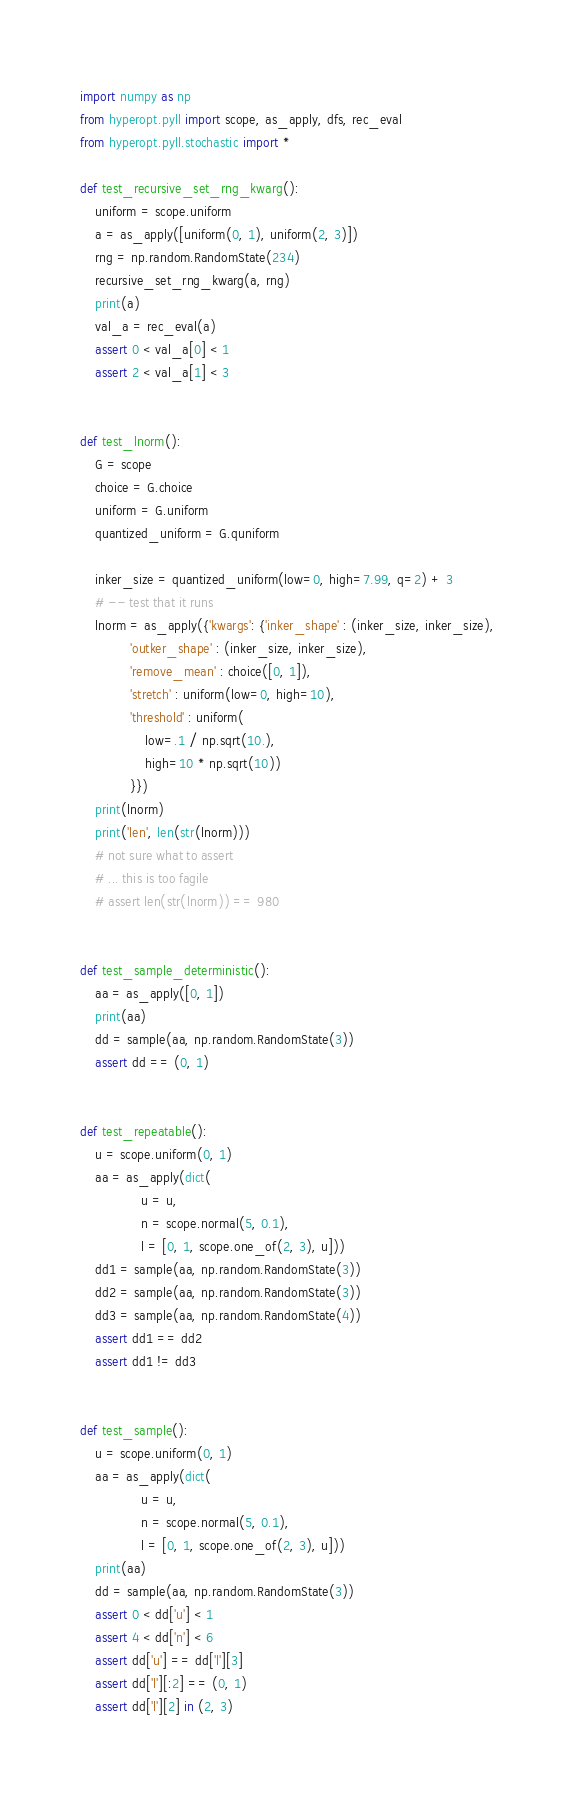<code> <loc_0><loc_0><loc_500><loc_500><_Python_>import numpy as np
from hyperopt.pyll import scope, as_apply, dfs, rec_eval
from hyperopt.pyll.stochastic import *

def test_recursive_set_rng_kwarg():
    uniform = scope.uniform
    a = as_apply([uniform(0, 1), uniform(2, 3)])
    rng = np.random.RandomState(234)
    recursive_set_rng_kwarg(a, rng)
    print(a)
    val_a = rec_eval(a)
    assert 0 < val_a[0] < 1
    assert 2 < val_a[1] < 3


def test_lnorm():
    G = scope
    choice = G.choice
    uniform = G.uniform
    quantized_uniform = G.quniform

    inker_size = quantized_uniform(low=0, high=7.99, q=2) + 3
    # -- test that it runs
    lnorm = as_apply({'kwargs': {'inker_shape' : (inker_size, inker_size),
             'outker_shape' : (inker_size, inker_size),
             'remove_mean' : choice([0, 1]),
             'stretch' : uniform(low=0, high=10),
             'threshold' : uniform(
                 low=.1 / np.sqrt(10.),
                 high=10 * np.sqrt(10))
             }})
    print(lnorm)
    print('len', len(str(lnorm)))
    # not sure what to assert
    # ... this is too fagile
    # assert len(str(lnorm)) == 980


def test_sample_deterministic():
    aa = as_apply([0, 1])
    print(aa)
    dd = sample(aa, np.random.RandomState(3))
    assert dd == (0, 1)


def test_repeatable():
    u = scope.uniform(0, 1)
    aa = as_apply(dict(
                u = u,
                n = scope.normal(5, 0.1),
                l = [0, 1, scope.one_of(2, 3), u]))
    dd1 = sample(aa, np.random.RandomState(3))
    dd2 = sample(aa, np.random.RandomState(3))
    dd3 = sample(aa, np.random.RandomState(4))
    assert dd1 == dd2
    assert dd1 != dd3


def test_sample():
    u = scope.uniform(0, 1)
    aa = as_apply(dict(
                u = u,
                n = scope.normal(5, 0.1),
                l = [0, 1, scope.one_of(2, 3), u]))
    print(aa)
    dd = sample(aa, np.random.RandomState(3))
    assert 0 < dd['u'] < 1
    assert 4 < dd['n'] < 6
    assert dd['u'] == dd['l'][3]
    assert dd['l'][:2] == (0, 1)
    assert dd['l'][2] in (2, 3)

</code> 